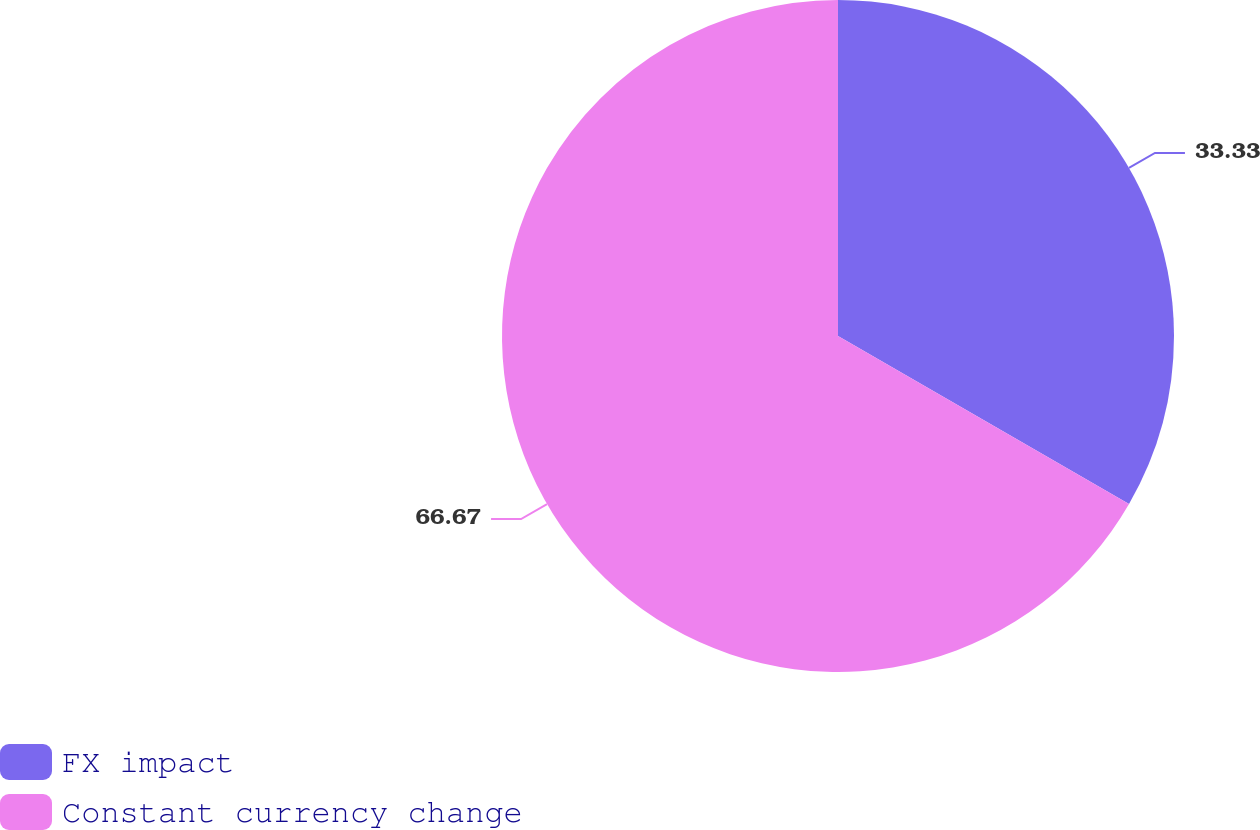Convert chart to OTSL. <chart><loc_0><loc_0><loc_500><loc_500><pie_chart><fcel>FX impact<fcel>Constant currency change<nl><fcel>33.33%<fcel>66.67%<nl></chart> 